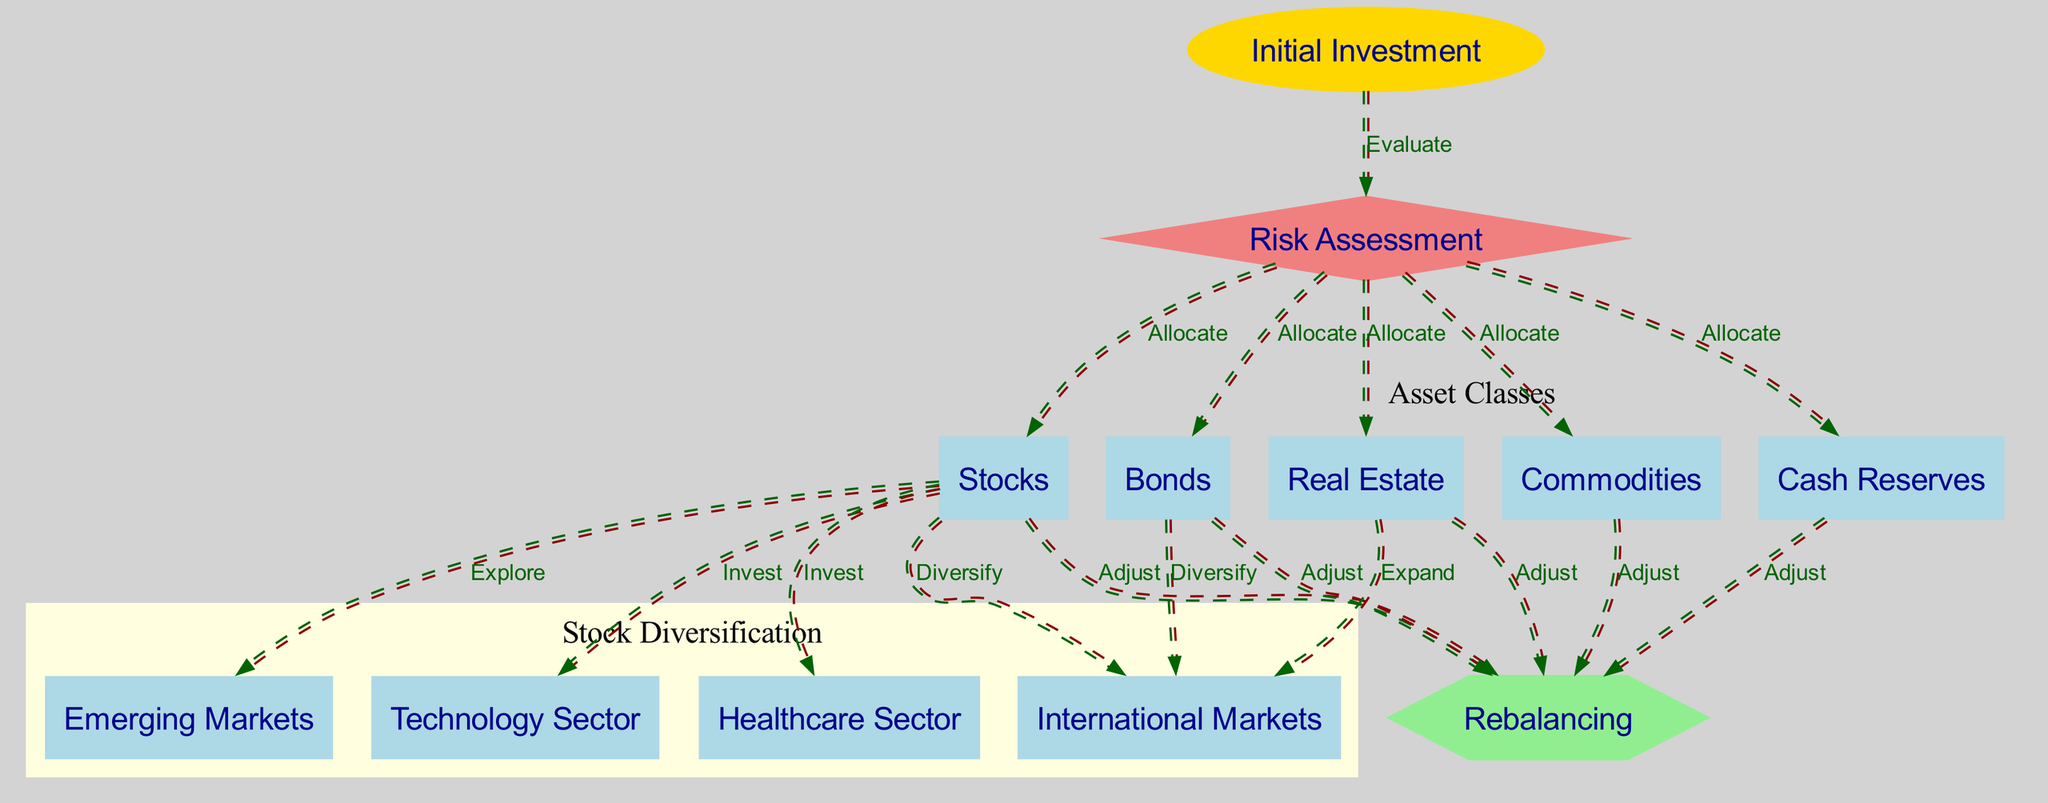What is the starting point of the investment process? The starting point, as indicated in the diagram, is the "Initial Investment" node, which is where the investment strategy begins.
Answer: Initial Investment How many nodes represent asset classes? In the diagram, there are five nodes that represent asset classes: "Stocks," "Bonds," "Real Estate," "Commodities," and "Cash Reserves." Counting these gives a total of five asset class nodes.
Answer: 5 What action follows "Risk Assessment"? After "Risk Assessment," the next actions are the allocation of assets to "Stocks," "Bonds," "Real Estate," "Commodities," and "Cash Reserves." Therefore, the first action immediately following is asset allocation.
Answer: Allocate Which sectors are diversifying from "Stocks"? The sectors that are diversifying from "Stocks" include "International Markets," "Emerging Markets," "Technology Sector," and "Healthcare Sector." These nodes specify where the diversification will occur.
Answer: International Markets, Emerging Markets, Technology Sector, Healthcare Sector What is one purpose of "Rebalancing"? The purpose of "Rebalancing" in the diagram is to adjust the asset allocations of "Stocks," "Bonds," "Real Estate," "Commodities," and "Cash Reserves." This reflects the need to maintain desired risk levels over time.
Answer: Adjust Which asset class expands into international markets? The asset class that expands into international markets as shown in the diagram is "Real Estate," which indicates a strategy to broaden its investment scope geographically.
Answer: Real Estate How many actions involve adjusting allocations? There are five actions outlined that involve adjusting allocations to various asset classes leading to the "Rebalancing" node: for "Stocks," "Bonds," "Real Estate," "Commodities," and "Cash Reserves." This results in a total of five actions.
Answer: 5 What traffic flows from "Initial Investment" to "Risk Assessment"? The flow from "Initial Investment" to "Risk Assessment" is labeled "Evaluate," indicating that this step involves assessing the initial investment before allocating assets.
Answer: Evaluate What shape represents the "Risk Assessment" node? The "Risk Assessment" node is represented in the diagram by a diamond shape, indicating a decision-making point in the investment strategy.
Answer: Diamond 